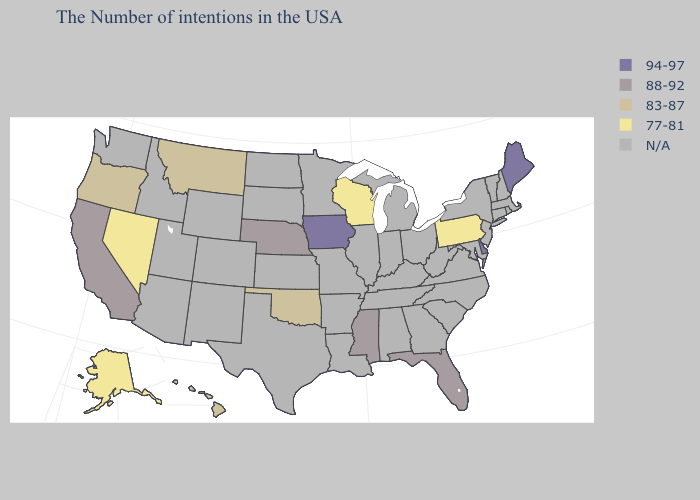What is the lowest value in the MidWest?
Keep it brief. 77-81. Name the states that have a value in the range 83-87?
Concise answer only. Oklahoma, Montana, Oregon, Hawaii. Which states have the lowest value in the USA?
Quick response, please. Pennsylvania, Wisconsin, Nevada, Alaska. What is the value of North Dakota?
Keep it brief. N/A. What is the value of Arizona?
Short answer required. N/A. Among the states that border Nebraska , which have the highest value?
Write a very short answer. Iowa. Name the states that have a value in the range 83-87?
Give a very brief answer. Oklahoma, Montana, Oregon, Hawaii. What is the lowest value in the USA?
Give a very brief answer. 77-81. Which states have the lowest value in the USA?
Give a very brief answer. Pennsylvania, Wisconsin, Nevada, Alaska. Name the states that have a value in the range 88-92?
Concise answer only. Florida, Mississippi, Nebraska, California. Name the states that have a value in the range 88-92?
Answer briefly. Florida, Mississippi, Nebraska, California. Name the states that have a value in the range 88-92?
Answer briefly. Florida, Mississippi, Nebraska, California. How many symbols are there in the legend?
Give a very brief answer. 5. Name the states that have a value in the range 88-92?
Keep it brief. Florida, Mississippi, Nebraska, California. 